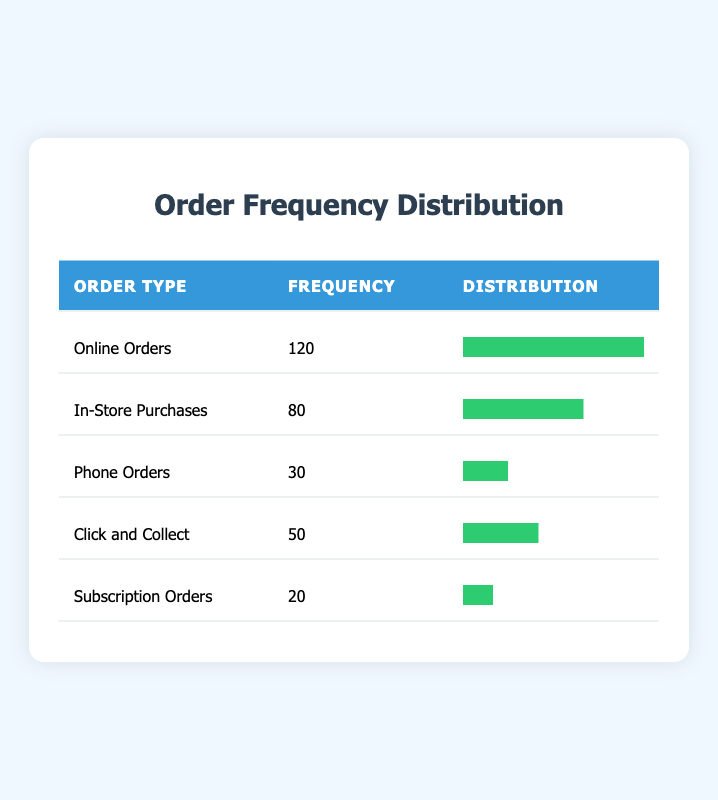What is the frequency of online orders? The frequency of online orders is directly listed in the table under the "Frequency" column for "Online Orders," which shows the value as 120.
Answer: 120 How many in-store purchases were made? The table provides the frequency of in-store purchases directly, which is listed as 80 under the "Frequency" column.
Answer: 80 What is the total frequency of all order types? To find the total frequency, add the frequencies of all order types: 120 (Online Orders) + 80 (In-Store Purchases) + 30 (Phone Orders) + 50 (Click and Collect) + 20 (Subscription Orders) = 300.
Answer: 300 How many more online orders were there compared to in-store purchases? To find the difference, subtract the frequency of in-store purchases from online orders: 120 (Online Orders) - 80 (In-Store Purchases) = 40.
Answer: 40 Is the frequency of phone orders greater than in-store purchases? By comparing the two frequencies, the frequency of phone orders is 30, while in-store purchases have a frequency of 80. Since 30 is less than 80, the answer is no.
Answer: No What percentage of total orders are click and collect? First, find the total: 300. Then, calculate the percentage of click and collect: (50/300) * 100 = 16.67%.
Answer: 16.67% If I combine the frequency of phone orders and subscription orders, how does it compare to in-store purchases? First, sum the frequencies of phone orders (30) and subscription orders (20): 30 + 20 = 50. Then compare it with in-store purchases’ frequency of 80. Since 50 is less than 80, the frequency of phone and subscription orders combined is less than in-store purchases.
Answer: Less How many total orders are represented by online and click and collect combined? Add the frequencies of online orders (120) and click and collect (50): 120 + 50 = 170.
Answer: 170 What is the average frequency of orders across all types? To find the average frequency, sum all frequencies: 300 (as calculated previously) and divide by the number of order types, which is 5: 300 / 5 = 60.
Answer: 60 